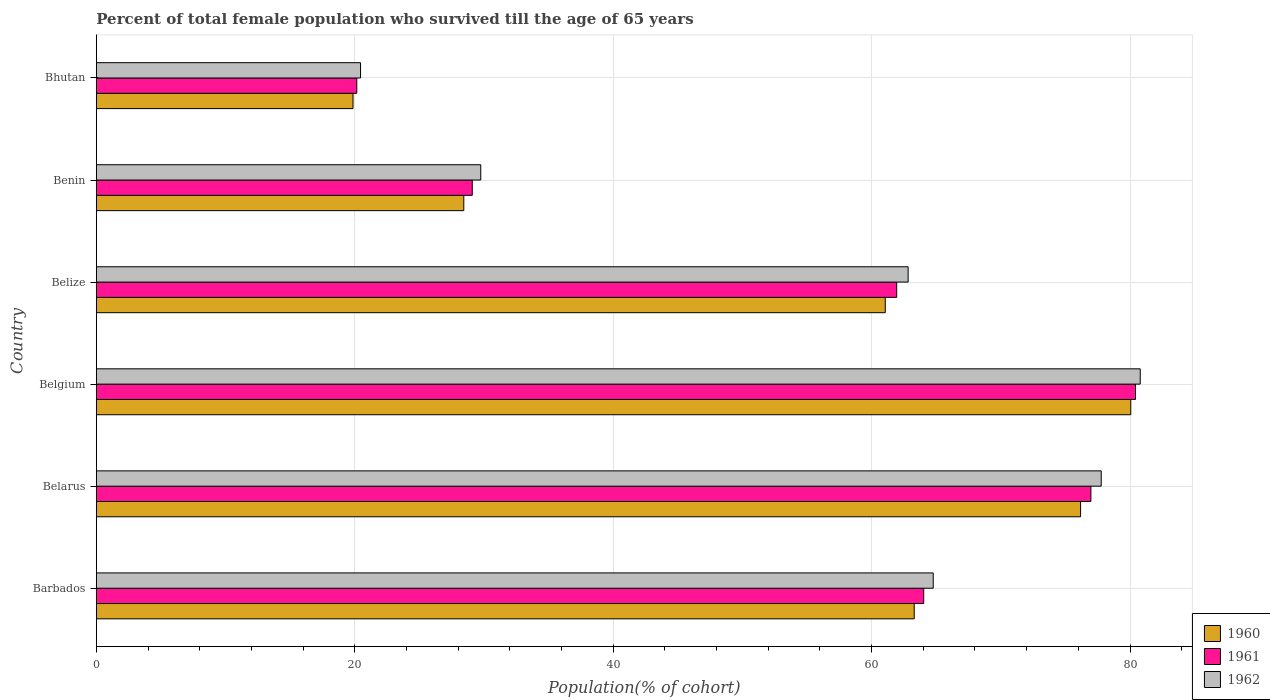How many different coloured bars are there?
Offer a very short reply. 3. Are the number of bars per tick equal to the number of legend labels?
Provide a short and direct response. Yes. Are the number of bars on each tick of the Y-axis equal?
Ensure brevity in your answer.  Yes. How many bars are there on the 4th tick from the bottom?
Your answer should be very brief. 3. What is the label of the 2nd group of bars from the top?
Offer a terse response. Benin. What is the percentage of total female population who survived till the age of 65 years in 1961 in Belgium?
Give a very brief answer. 80.43. Across all countries, what is the maximum percentage of total female population who survived till the age of 65 years in 1961?
Offer a very short reply. 80.43. Across all countries, what is the minimum percentage of total female population who survived till the age of 65 years in 1960?
Make the answer very short. 19.87. In which country was the percentage of total female population who survived till the age of 65 years in 1961 minimum?
Offer a terse response. Bhutan. What is the total percentage of total female population who survived till the age of 65 years in 1961 in the graph?
Ensure brevity in your answer.  332.63. What is the difference between the percentage of total female population who survived till the age of 65 years in 1960 in Belarus and that in Benin?
Your answer should be compact. 47.74. What is the difference between the percentage of total female population who survived till the age of 65 years in 1960 in Bhutan and the percentage of total female population who survived till the age of 65 years in 1962 in Benin?
Offer a terse response. -9.89. What is the average percentage of total female population who survived till the age of 65 years in 1960 per country?
Ensure brevity in your answer.  54.82. What is the difference between the percentage of total female population who survived till the age of 65 years in 1960 and percentage of total female population who survived till the age of 65 years in 1961 in Belarus?
Your answer should be compact. -0.8. In how many countries, is the percentage of total female population who survived till the age of 65 years in 1961 greater than 72 %?
Provide a succinct answer. 2. What is the ratio of the percentage of total female population who survived till the age of 65 years in 1960 in Belgium to that in Bhutan?
Ensure brevity in your answer.  4.03. What is the difference between the highest and the second highest percentage of total female population who survived till the age of 65 years in 1961?
Your answer should be compact. 3.45. What is the difference between the highest and the lowest percentage of total female population who survived till the age of 65 years in 1961?
Your response must be concise. 60.27. In how many countries, is the percentage of total female population who survived till the age of 65 years in 1962 greater than the average percentage of total female population who survived till the age of 65 years in 1962 taken over all countries?
Your answer should be compact. 4. What does the 2nd bar from the bottom in Belize represents?
Your response must be concise. 1961. How many bars are there?
Your response must be concise. 18. Does the graph contain grids?
Provide a succinct answer. Yes. What is the title of the graph?
Offer a very short reply. Percent of total female population who survived till the age of 65 years. What is the label or title of the X-axis?
Ensure brevity in your answer.  Population(% of cohort). What is the Population(% of cohort) in 1960 in Barbados?
Your response must be concise. 63.3. What is the Population(% of cohort) of 1961 in Barbados?
Give a very brief answer. 64.04. What is the Population(% of cohort) of 1962 in Barbados?
Offer a terse response. 64.77. What is the Population(% of cohort) in 1960 in Belarus?
Offer a very short reply. 76.18. What is the Population(% of cohort) of 1961 in Belarus?
Offer a very short reply. 76.97. What is the Population(% of cohort) in 1962 in Belarus?
Ensure brevity in your answer.  77.77. What is the Population(% of cohort) of 1960 in Belgium?
Offer a very short reply. 80.06. What is the Population(% of cohort) in 1961 in Belgium?
Make the answer very short. 80.43. What is the Population(% of cohort) of 1962 in Belgium?
Make the answer very short. 80.79. What is the Population(% of cohort) of 1960 in Belize?
Offer a terse response. 61.06. What is the Population(% of cohort) in 1961 in Belize?
Your answer should be very brief. 61.94. What is the Population(% of cohort) in 1962 in Belize?
Keep it short and to the point. 62.83. What is the Population(% of cohort) of 1960 in Benin?
Give a very brief answer. 28.44. What is the Population(% of cohort) in 1961 in Benin?
Provide a succinct answer. 29.1. What is the Population(% of cohort) of 1962 in Benin?
Your answer should be compact. 29.75. What is the Population(% of cohort) in 1960 in Bhutan?
Your answer should be very brief. 19.87. What is the Population(% of cohort) in 1961 in Bhutan?
Make the answer very short. 20.16. What is the Population(% of cohort) of 1962 in Bhutan?
Ensure brevity in your answer.  20.45. Across all countries, what is the maximum Population(% of cohort) in 1960?
Give a very brief answer. 80.06. Across all countries, what is the maximum Population(% of cohort) of 1961?
Provide a succinct answer. 80.43. Across all countries, what is the maximum Population(% of cohort) in 1962?
Keep it short and to the point. 80.79. Across all countries, what is the minimum Population(% of cohort) in 1960?
Your answer should be very brief. 19.87. Across all countries, what is the minimum Population(% of cohort) in 1961?
Give a very brief answer. 20.16. Across all countries, what is the minimum Population(% of cohort) in 1962?
Keep it short and to the point. 20.45. What is the total Population(% of cohort) of 1960 in the graph?
Make the answer very short. 328.9. What is the total Population(% of cohort) of 1961 in the graph?
Offer a terse response. 332.63. What is the total Population(% of cohort) in 1962 in the graph?
Keep it short and to the point. 336.37. What is the difference between the Population(% of cohort) in 1960 in Barbados and that in Belarus?
Your answer should be very brief. -12.88. What is the difference between the Population(% of cohort) in 1961 in Barbados and that in Belarus?
Your answer should be very brief. -12.94. What is the difference between the Population(% of cohort) of 1962 in Barbados and that in Belarus?
Offer a terse response. -13. What is the difference between the Population(% of cohort) in 1960 in Barbados and that in Belgium?
Provide a short and direct response. -16.76. What is the difference between the Population(% of cohort) in 1961 in Barbados and that in Belgium?
Keep it short and to the point. -16.39. What is the difference between the Population(% of cohort) in 1962 in Barbados and that in Belgium?
Offer a very short reply. -16.02. What is the difference between the Population(% of cohort) in 1960 in Barbados and that in Belize?
Ensure brevity in your answer.  2.24. What is the difference between the Population(% of cohort) of 1961 in Barbados and that in Belize?
Your answer should be very brief. 2.09. What is the difference between the Population(% of cohort) in 1962 in Barbados and that in Belize?
Provide a succinct answer. 1.94. What is the difference between the Population(% of cohort) of 1960 in Barbados and that in Benin?
Provide a short and direct response. 34.86. What is the difference between the Population(% of cohort) in 1961 in Barbados and that in Benin?
Provide a short and direct response. 34.94. What is the difference between the Population(% of cohort) in 1962 in Barbados and that in Benin?
Your answer should be compact. 35.02. What is the difference between the Population(% of cohort) in 1960 in Barbados and that in Bhutan?
Ensure brevity in your answer.  43.43. What is the difference between the Population(% of cohort) of 1961 in Barbados and that in Bhutan?
Keep it short and to the point. 43.88. What is the difference between the Population(% of cohort) in 1962 in Barbados and that in Bhutan?
Offer a terse response. 44.32. What is the difference between the Population(% of cohort) in 1960 in Belarus and that in Belgium?
Provide a short and direct response. -3.89. What is the difference between the Population(% of cohort) in 1961 in Belarus and that in Belgium?
Your response must be concise. -3.45. What is the difference between the Population(% of cohort) in 1962 in Belarus and that in Belgium?
Make the answer very short. -3.02. What is the difference between the Population(% of cohort) of 1960 in Belarus and that in Belize?
Your answer should be compact. 15.12. What is the difference between the Population(% of cohort) of 1961 in Belarus and that in Belize?
Make the answer very short. 15.03. What is the difference between the Population(% of cohort) in 1962 in Belarus and that in Belize?
Keep it short and to the point. 14.94. What is the difference between the Population(% of cohort) in 1960 in Belarus and that in Benin?
Provide a succinct answer. 47.74. What is the difference between the Population(% of cohort) of 1961 in Belarus and that in Benin?
Keep it short and to the point. 47.88. What is the difference between the Population(% of cohort) of 1962 in Belarus and that in Benin?
Provide a succinct answer. 48.02. What is the difference between the Population(% of cohort) of 1960 in Belarus and that in Bhutan?
Your answer should be compact. 56.31. What is the difference between the Population(% of cohort) of 1961 in Belarus and that in Bhutan?
Provide a succinct answer. 56.82. What is the difference between the Population(% of cohort) of 1962 in Belarus and that in Bhutan?
Your response must be concise. 57.33. What is the difference between the Population(% of cohort) of 1960 in Belgium and that in Belize?
Your answer should be very brief. 19. What is the difference between the Population(% of cohort) of 1961 in Belgium and that in Belize?
Keep it short and to the point. 18.48. What is the difference between the Population(% of cohort) in 1962 in Belgium and that in Belize?
Keep it short and to the point. 17.96. What is the difference between the Population(% of cohort) of 1960 in Belgium and that in Benin?
Keep it short and to the point. 51.62. What is the difference between the Population(% of cohort) in 1961 in Belgium and that in Benin?
Your answer should be compact. 51.33. What is the difference between the Population(% of cohort) of 1962 in Belgium and that in Benin?
Keep it short and to the point. 51.04. What is the difference between the Population(% of cohort) of 1960 in Belgium and that in Bhutan?
Ensure brevity in your answer.  60.19. What is the difference between the Population(% of cohort) of 1961 in Belgium and that in Bhutan?
Your response must be concise. 60.27. What is the difference between the Population(% of cohort) of 1962 in Belgium and that in Bhutan?
Your response must be concise. 60.34. What is the difference between the Population(% of cohort) of 1960 in Belize and that in Benin?
Give a very brief answer. 32.62. What is the difference between the Population(% of cohort) of 1961 in Belize and that in Benin?
Ensure brevity in your answer.  32.85. What is the difference between the Population(% of cohort) of 1962 in Belize and that in Benin?
Offer a very short reply. 33.08. What is the difference between the Population(% of cohort) in 1960 in Belize and that in Bhutan?
Provide a succinct answer. 41.19. What is the difference between the Population(% of cohort) in 1961 in Belize and that in Bhutan?
Give a very brief answer. 41.79. What is the difference between the Population(% of cohort) of 1962 in Belize and that in Bhutan?
Your answer should be very brief. 42.38. What is the difference between the Population(% of cohort) of 1960 in Benin and that in Bhutan?
Ensure brevity in your answer.  8.57. What is the difference between the Population(% of cohort) of 1961 in Benin and that in Bhutan?
Offer a very short reply. 8.94. What is the difference between the Population(% of cohort) of 1962 in Benin and that in Bhutan?
Provide a succinct answer. 9.3. What is the difference between the Population(% of cohort) in 1960 in Barbados and the Population(% of cohort) in 1961 in Belarus?
Your response must be concise. -13.67. What is the difference between the Population(% of cohort) of 1960 in Barbados and the Population(% of cohort) of 1962 in Belarus?
Make the answer very short. -14.47. What is the difference between the Population(% of cohort) of 1961 in Barbados and the Population(% of cohort) of 1962 in Belarus?
Your answer should be compact. -13.74. What is the difference between the Population(% of cohort) of 1960 in Barbados and the Population(% of cohort) of 1961 in Belgium?
Your answer should be compact. -17.13. What is the difference between the Population(% of cohort) of 1960 in Barbados and the Population(% of cohort) of 1962 in Belgium?
Offer a very short reply. -17.49. What is the difference between the Population(% of cohort) in 1961 in Barbados and the Population(% of cohort) in 1962 in Belgium?
Offer a terse response. -16.76. What is the difference between the Population(% of cohort) in 1960 in Barbados and the Population(% of cohort) in 1961 in Belize?
Keep it short and to the point. 1.35. What is the difference between the Population(% of cohort) of 1960 in Barbados and the Population(% of cohort) of 1962 in Belize?
Offer a terse response. 0.47. What is the difference between the Population(% of cohort) of 1961 in Barbados and the Population(% of cohort) of 1962 in Belize?
Your answer should be compact. 1.21. What is the difference between the Population(% of cohort) of 1960 in Barbados and the Population(% of cohort) of 1961 in Benin?
Give a very brief answer. 34.2. What is the difference between the Population(% of cohort) of 1960 in Barbados and the Population(% of cohort) of 1962 in Benin?
Provide a short and direct response. 33.55. What is the difference between the Population(% of cohort) of 1961 in Barbados and the Population(% of cohort) of 1962 in Benin?
Offer a very short reply. 34.28. What is the difference between the Population(% of cohort) in 1960 in Barbados and the Population(% of cohort) in 1961 in Bhutan?
Give a very brief answer. 43.14. What is the difference between the Population(% of cohort) in 1960 in Barbados and the Population(% of cohort) in 1962 in Bhutan?
Make the answer very short. 42.85. What is the difference between the Population(% of cohort) in 1961 in Barbados and the Population(% of cohort) in 1962 in Bhutan?
Keep it short and to the point. 43.59. What is the difference between the Population(% of cohort) in 1960 in Belarus and the Population(% of cohort) in 1961 in Belgium?
Ensure brevity in your answer.  -4.25. What is the difference between the Population(% of cohort) in 1960 in Belarus and the Population(% of cohort) in 1962 in Belgium?
Offer a terse response. -4.62. What is the difference between the Population(% of cohort) in 1961 in Belarus and the Population(% of cohort) in 1962 in Belgium?
Your answer should be very brief. -3.82. What is the difference between the Population(% of cohort) of 1960 in Belarus and the Population(% of cohort) of 1961 in Belize?
Offer a terse response. 14.23. What is the difference between the Population(% of cohort) of 1960 in Belarus and the Population(% of cohort) of 1962 in Belize?
Ensure brevity in your answer.  13.35. What is the difference between the Population(% of cohort) in 1961 in Belarus and the Population(% of cohort) in 1962 in Belize?
Provide a short and direct response. 14.14. What is the difference between the Population(% of cohort) of 1960 in Belarus and the Population(% of cohort) of 1961 in Benin?
Your answer should be very brief. 47.08. What is the difference between the Population(% of cohort) of 1960 in Belarus and the Population(% of cohort) of 1962 in Benin?
Give a very brief answer. 46.42. What is the difference between the Population(% of cohort) in 1961 in Belarus and the Population(% of cohort) in 1962 in Benin?
Ensure brevity in your answer.  47.22. What is the difference between the Population(% of cohort) of 1960 in Belarus and the Population(% of cohort) of 1961 in Bhutan?
Your answer should be compact. 56.02. What is the difference between the Population(% of cohort) of 1960 in Belarus and the Population(% of cohort) of 1962 in Bhutan?
Make the answer very short. 55.73. What is the difference between the Population(% of cohort) of 1961 in Belarus and the Population(% of cohort) of 1962 in Bhutan?
Your answer should be very brief. 56.53. What is the difference between the Population(% of cohort) of 1960 in Belgium and the Population(% of cohort) of 1961 in Belize?
Keep it short and to the point. 18.12. What is the difference between the Population(% of cohort) in 1960 in Belgium and the Population(% of cohort) in 1962 in Belize?
Provide a succinct answer. 17.23. What is the difference between the Population(% of cohort) in 1961 in Belgium and the Population(% of cohort) in 1962 in Belize?
Make the answer very short. 17.6. What is the difference between the Population(% of cohort) of 1960 in Belgium and the Population(% of cohort) of 1961 in Benin?
Your response must be concise. 50.97. What is the difference between the Population(% of cohort) of 1960 in Belgium and the Population(% of cohort) of 1962 in Benin?
Make the answer very short. 50.31. What is the difference between the Population(% of cohort) in 1961 in Belgium and the Population(% of cohort) in 1962 in Benin?
Ensure brevity in your answer.  50.68. What is the difference between the Population(% of cohort) of 1960 in Belgium and the Population(% of cohort) of 1961 in Bhutan?
Make the answer very short. 59.9. What is the difference between the Population(% of cohort) of 1960 in Belgium and the Population(% of cohort) of 1962 in Bhutan?
Your answer should be very brief. 59.61. What is the difference between the Population(% of cohort) of 1961 in Belgium and the Population(% of cohort) of 1962 in Bhutan?
Provide a short and direct response. 59.98. What is the difference between the Population(% of cohort) of 1960 in Belize and the Population(% of cohort) of 1961 in Benin?
Keep it short and to the point. 31.96. What is the difference between the Population(% of cohort) in 1960 in Belize and the Population(% of cohort) in 1962 in Benin?
Provide a succinct answer. 31.31. What is the difference between the Population(% of cohort) of 1961 in Belize and the Population(% of cohort) of 1962 in Benin?
Ensure brevity in your answer.  32.19. What is the difference between the Population(% of cohort) in 1960 in Belize and the Population(% of cohort) in 1961 in Bhutan?
Your answer should be compact. 40.9. What is the difference between the Population(% of cohort) of 1960 in Belize and the Population(% of cohort) of 1962 in Bhutan?
Provide a short and direct response. 40.61. What is the difference between the Population(% of cohort) in 1961 in Belize and the Population(% of cohort) in 1962 in Bhutan?
Ensure brevity in your answer.  41.5. What is the difference between the Population(% of cohort) in 1960 in Benin and the Population(% of cohort) in 1961 in Bhutan?
Make the answer very short. 8.28. What is the difference between the Population(% of cohort) in 1960 in Benin and the Population(% of cohort) in 1962 in Bhutan?
Provide a short and direct response. 7.99. What is the difference between the Population(% of cohort) of 1961 in Benin and the Population(% of cohort) of 1962 in Bhutan?
Your response must be concise. 8.65. What is the average Population(% of cohort) of 1960 per country?
Your response must be concise. 54.82. What is the average Population(% of cohort) of 1961 per country?
Your response must be concise. 55.44. What is the average Population(% of cohort) in 1962 per country?
Give a very brief answer. 56.06. What is the difference between the Population(% of cohort) of 1960 and Population(% of cohort) of 1961 in Barbados?
Provide a succinct answer. -0.74. What is the difference between the Population(% of cohort) of 1960 and Population(% of cohort) of 1962 in Barbados?
Offer a terse response. -1.47. What is the difference between the Population(% of cohort) of 1961 and Population(% of cohort) of 1962 in Barbados?
Provide a succinct answer. -0.74. What is the difference between the Population(% of cohort) in 1960 and Population(% of cohort) in 1961 in Belarus?
Offer a terse response. -0.8. What is the difference between the Population(% of cohort) in 1960 and Population(% of cohort) in 1962 in Belarus?
Offer a terse response. -1.6. What is the difference between the Population(% of cohort) of 1961 and Population(% of cohort) of 1962 in Belarus?
Your answer should be compact. -0.8. What is the difference between the Population(% of cohort) in 1960 and Population(% of cohort) in 1961 in Belgium?
Your response must be concise. -0.37. What is the difference between the Population(% of cohort) of 1960 and Population(% of cohort) of 1962 in Belgium?
Ensure brevity in your answer.  -0.73. What is the difference between the Population(% of cohort) in 1961 and Population(% of cohort) in 1962 in Belgium?
Keep it short and to the point. -0.37. What is the difference between the Population(% of cohort) in 1960 and Population(% of cohort) in 1961 in Belize?
Provide a short and direct response. -0.88. What is the difference between the Population(% of cohort) of 1960 and Population(% of cohort) of 1962 in Belize?
Make the answer very short. -1.77. What is the difference between the Population(% of cohort) of 1961 and Population(% of cohort) of 1962 in Belize?
Ensure brevity in your answer.  -0.88. What is the difference between the Population(% of cohort) in 1960 and Population(% of cohort) in 1961 in Benin?
Your answer should be very brief. -0.66. What is the difference between the Population(% of cohort) of 1960 and Population(% of cohort) of 1962 in Benin?
Provide a succinct answer. -1.31. What is the difference between the Population(% of cohort) of 1961 and Population(% of cohort) of 1962 in Benin?
Keep it short and to the point. -0.66. What is the difference between the Population(% of cohort) in 1960 and Population(% of cohort) in 1961 in Bhutan?
Keep it short and to the point. -0.29. What is the difference between the Population(% of cohort) in 1960 and Population(% of cohort) in 1962 in Bhutan?
Ensure brevity in your answer.  -0.58. What is the difference between the Population(% of cohort) of 1961 and Population(% of cohort) of 1962 in Bhutan?
Your answer should be very brief. -0.29. What is the ratio of the Population(% of cohort) of 1960 in Barbados to that in Belarus?
Your response must be concise. 0.83. What is the ratio of the Population(% of cohort) in 1961 in Barbados to that in Belarus?
Make the answer very short. 0.83. What is the ratio of the Population(% of cohort) in 1962 in Barbados to that in Belarus?
Your answer should be compact. 0.83. What is the ratio of the Population(% of cohort) in 1960 in Barbados to that in Belgium?
Ensure brevity in your answer.  0.79. What is the ratio of the Population(% of cohort) of 1961 in Barbados to that in Belgium?
Make the answer very short. 0.8. What is the ratio of the Population(% of cohort) of 1962 in Barbados to that in Belgium?
Your answer should be compact. 0.8. What is the ratio of the Population(% of cohort) of 1960 in Barbados to that in Belize?
Ensure brevity in your answer.  1.04. What is the ratio of the Population(% of cohort) in 1961 in Barbados to that in Belize?
Offer a very short reply. 1.03. What is the ratio of the Population(% of cohort) in 1962 in Barbados to that in Belize?
Your answer should be very brief. 1.03. What is the ratio of the Population(% of cohort) in 1960 in Barbados to that in Benin?
Give a very brief answer. 2.23. What is the ratio of the Population(% of cohort) of 1961 in Barbados to that in Benin?
Offer a terse response. 2.2. What is the ratio of the Population(% of cohort) in 1962 in Barbados to that in Benin?
Provide a succinct answer. 2.18. What is the ratio of the Population(% of cohort) of 1960 in Barbados to that in Bhutan?
Offer a terse response. 3.19. What is the ratio of the Population(% of cohort) of 1961 in Barbados to that in Bhutan?
Your response must be concise. 3.18. What is the ratio of the Population(% of cohort) in 1962 in Barbados to that in Bhutan?
Provide a short and direct response. 3.17. What is the ratio of the Population(% of cohort) in 1960 in Belarus to that in Belgium?
Ensure brevity in your answer.  0.95. What is the ratio of the Population(% of cohort) of 1961 in Belarus to that in Belgium?
Your answer should be compact. 0.96. What is the ratio of the Population(% of cohort) of 1962 in Belarus to that in Belgium?
Your answer should be compact. 0.96. What is the ratio of the Population(% of cohort) in 1960 in Belarus to that in Belize?
Keep it short and to the point. 1.25. What is the ratio of the Population(% of cohort) of 1961 in Belarus to that in Belize?
Your answer should be very brief. 1.24. What is the ratio of the Population(% of cohort) of 1962 in Belarus to that in Belize?
Keep it short and to the point. 1.24. What is the ratio of the Population(% of cohort) in 1960 in Belarus to that in Benin?
Ensure brevity in your answer.  2.68. What is the ratio of the Population(% of cohort) of 1961 in Belarus to that in Benin?
Make the answer very short. 2.65. What is the ratio of the Population(% of cohort) of 1962 in Belarus to that in Benin?
Offer a terse response. 2.61. What is the ratio of the Population(% of cohort) in 1960 in Belarus to that in Bhutan?
Keep it short and to the point. 3.83. What is the ratio of the Population(% of cohort) of 1961 in Belarus to that in Bhutan?
Provide a succinct answer. 3.82. What is the ratio of the Population(% of cohort) of 1962 in Belarus to that in Bhutan?
Give a very brief answer. 3.8. What is the ratio of the Population(% of cohort) of 1960 in Belgium to that in Belize?
Your answer should be compact. 1.31. What is the ratio of the Population(% of cohort) of 1961 in Belgium to that in Belize?
Keep it short and to the point. 1.3. What is the ratio of the Population(% of cohort) in 1962 in Belgium to that in Belize?
Your response must be concise. 1.29. What is the ratio of the Population(% of cohort) in 1960 in Belgium to that in Benin?
Ensure brevity in your answer.  2.82. What is the ratio of the Population(% of cohort) of 1961 in Belgium to that in Benin?
Provide a succinct answer. 2.76. What is the ratio of the Population(% of cohort) in 1962 in Belgium to that in Benin?
Make the answer very short. 2.72. What is the ratio of the Population(% of cohort) in 1960 in Belgium to that in Bhutan?
Provide a succinct answer. 4.03. What is the ratio of the Population(% of cohort) of 1961 in Belgium to that in Bhutan?
Provide a succinct answer. 3.99. What is the ratio of the Population(% of cohort) in 1962 in Belgium to that in Bhutan?
Give a very brief answer. 3.95. What is the ratio of the Population(% of cohort) in 1960 in Belize to that in Benin?
Provide a succinct answer. 2.15. What is the ratio of the Population(% of cohort) in 1961 in Belize to that in Benin?
Provide a short and direct response. 2.13. What is the ratio of the Population(% of cohort) in 1962 in Belize to that in Benin?
Your answer should be very brief. 2.11. What is the ratio of the Population(% of cohort) in 1960 in Belize to that in Bhutan?
Your answer should be very brief. 3.07. What is the ratio of the Population(% of cohort) in 1961 in Belize to that in Bhutan?
Make the answer very short. 3.07. What is the ratio of the Population(% of cohort) in 1962 in Belize to that in Bhutan?
Offer a terse response. 3.07. What is the ratio of the Population(% of cohort) of 1960 in Benin to that in Bhutan?
Provide a succinct answer. 1.43. What is the ratio of the Population(% of cohort) of 1961 in Benin to that in Bhutan?
Provide a short and direct response. 1.44. What is the ratio of the Population(% of cohort) of 1962 in Benin to that in Bhutan?
Provide a succinct answer. 1.46. What is the difference between the highest and the second highest Population(% of cohort) of 1960?
Provide a succinct answer. 3.89. What is the difference between the highest and the second highest Population(% of cohort) of 1961?
Your answer should be compact. 3.45. What is the difference between the highest and the second highest Population(% of cohort) in 1962?
Ensure brevity in your answer.  3.02. What is the difference between the highest and the lowest Population(% of cohort) in 1960?
Keep it short and to the point. 60.19. What is the difference between the highest and the lowest Population(% of cohort) of 1961?
Offer a terse response. 60.27. What is the difference between the highest and the lowest Population(% of cohort) of 1962?
Ensure brevity in your answer.  60.34. 